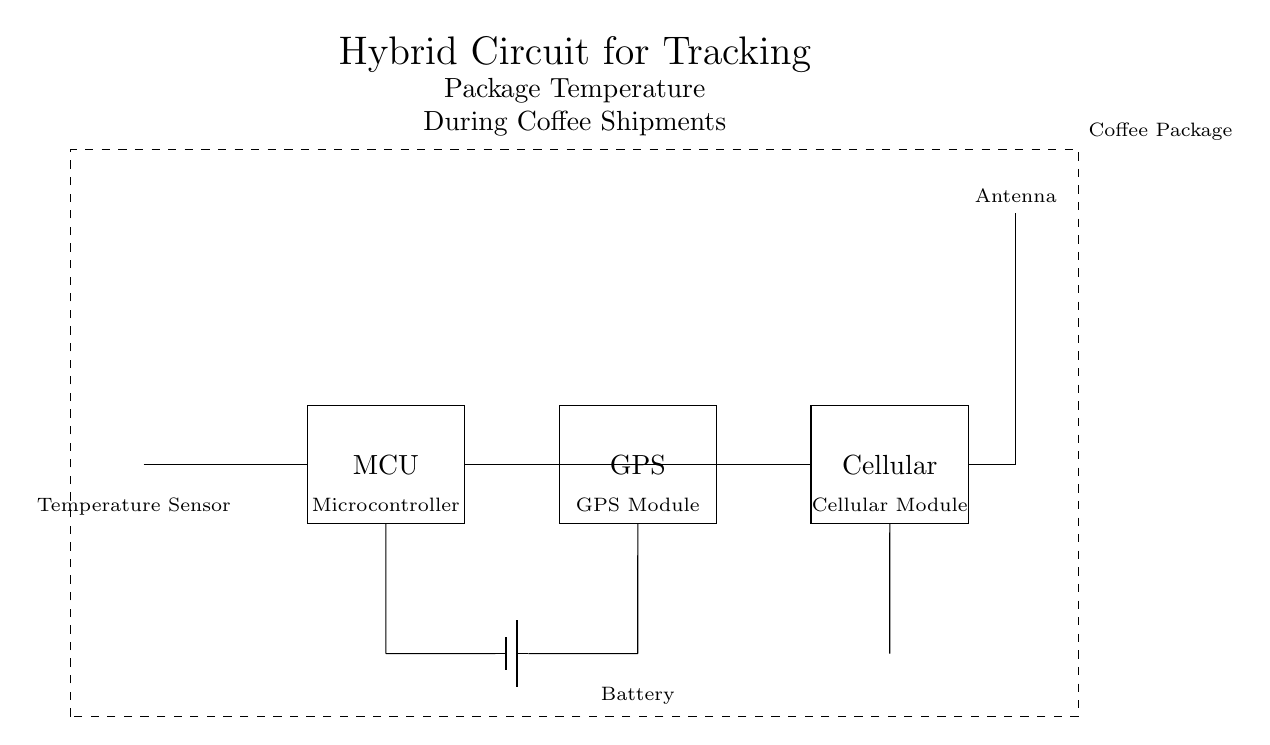What type of sensor is used in this circuit? The circuit includes a thermistor, which is a type of temperature sensor that changes resistance with temperature changes.
Answer: Thermistor What does the MCU control? The microcontroller (MCU) connects and controls the temperature sensor, GPS module, and cellular module, processing the data from each component.
Answer: Temperature sensor, GPS, cellular module How many modules are present in the circuit? The circuit diagram includes three main modules: the microcontroller, GPS module, and cellular module, in addition to the temperature sensor.
Answer: Four What is the purpose of the battery in this circuit? The battery provides power to the entire circuit, enabling all components to operate independently without an external power source.
Answer: Power supply Which component is responsible for communication? The cellular module facilitates communication by sending data, such as temperature readings and location, over the mobile network.
Answer: Cellular module How does the GPS module interact with the microcontroller? The GPS module receives location data and sends it to the microcontroller, which processes and may transmit this information along with temperature readings.
Answer: Via connections What is the main function of the antenna in this circuit? The antenna is used to transmit signals sent from the cellular module, allowing for communication with external networks, essential for real-time tracking.
Answer: Transmission 